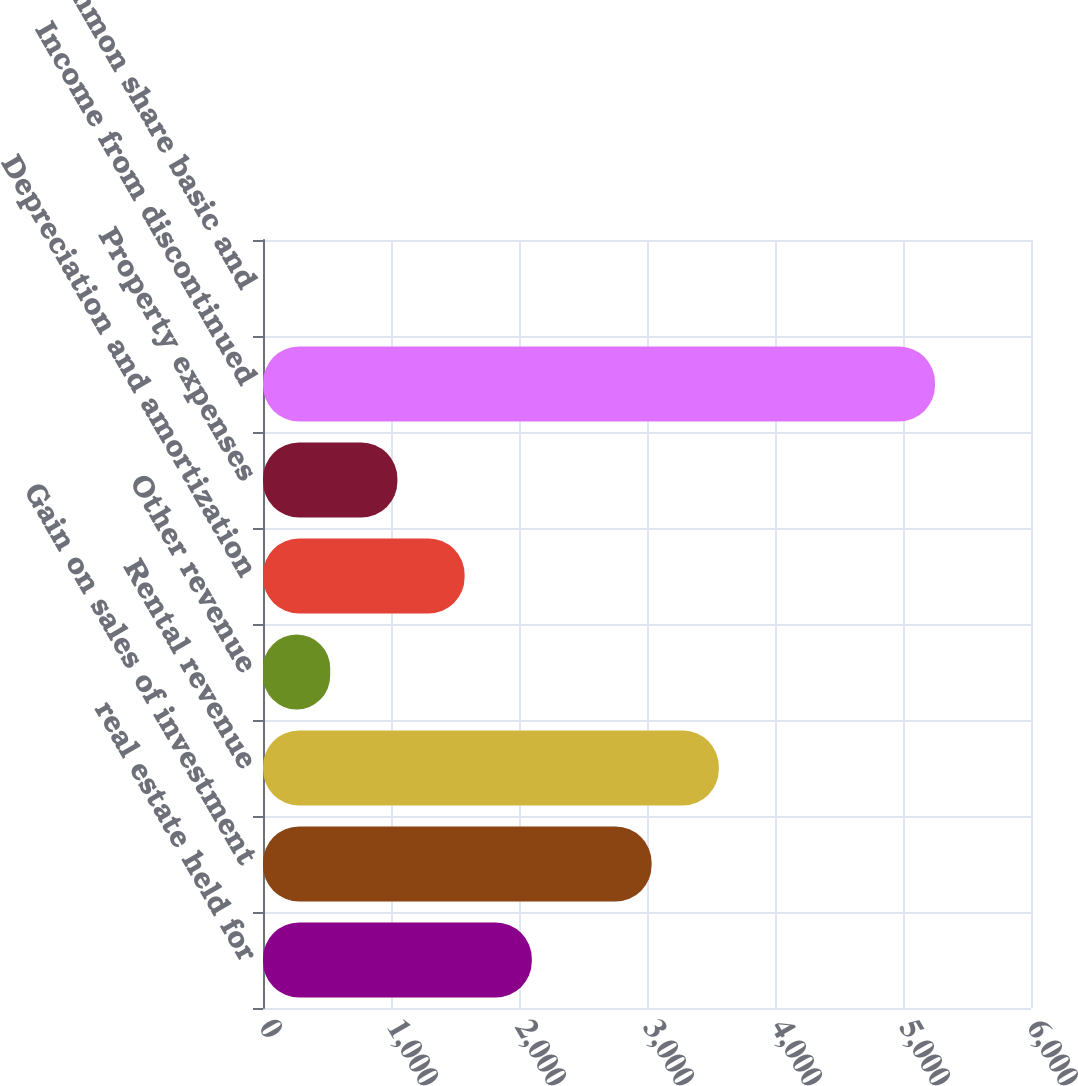Convert chart. <chart><loc_0><loc_0><loc_500><loc_500><bar_chart><fcel>real estate held for<fcel>Gain on sales of investment<fcel>Rental revenue<fcel>Other revenue<fcel>Depreciation and amortization<fcel>Property expenses<fcel>Income from discontinued<fcel>Per common share basic and<nl><fcel>2100.02<fcel>3036<fcel>3560.99<fcel>525.05<fcel>1575.03<fcel>1050.04<fcel>5250<fcel>0.06<nl></chart> 